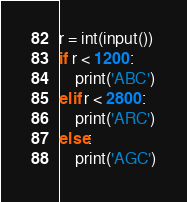<code> <loc_0><loc_0><loc_500><loc_500><_Python_>r = int(input())
if r < 1200:
    print('ABC')
elif r < 2800:
    print('ARC')
else:
    print('AGC')</code> 